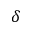Convert formula to latex. <formula><loc_0><loc_0><loc_500><loc_500>\delta</formula> 